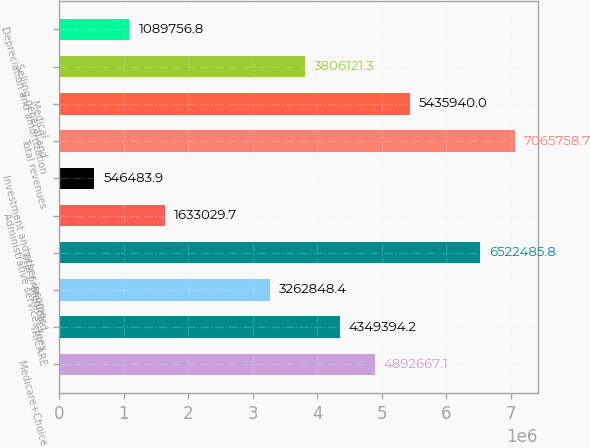Convert chart. <chart><loc_0><loc_0><loc_500><loc_500><bar_chart><fcel>Medicare+Choice<fcel>TRICARE<fcel>Medicaid<fcel>Total premiums<fcel>Administrative services fees<fcel>Investment and other income<fcel>Total revenues<fcel>Medical<fcel>Selling general and<fcel>Depreciation and amortization<nl><fcel>4.89267e+06<fcel>4.34939e+06<fcel>3.26285e+06<fcel>6.52249e+06<fcel>1.63303e+06<fcel>546484<fcel>7.06576e+06<fcel>5.43594e+06<fcel>3.80612e+06<fcel>1.08976e+06<nl></chart> 